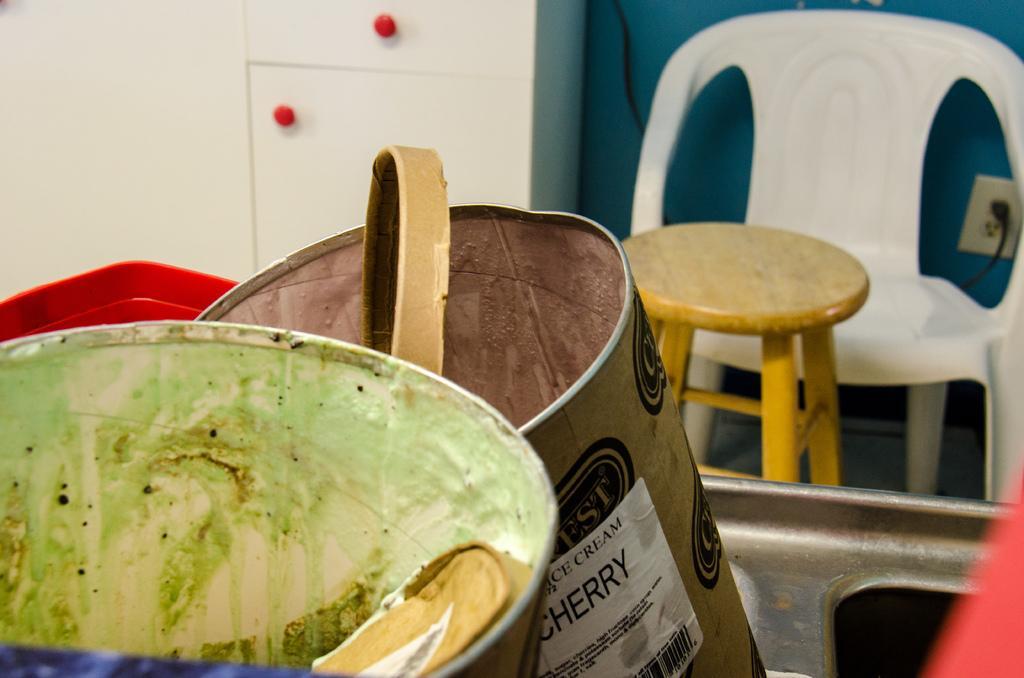Can you describe this image briefly? In this image we can see two paint containers are kept on the sink. Back ground of the image one cupboard, chair and table is present. The wall is in blue color with one switch board attached to it. 